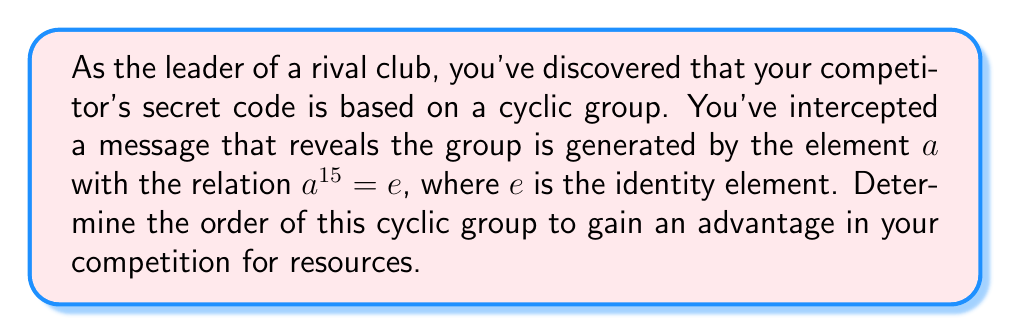Provide a solution to this math problem. To determine the order of a cyclic group generated by an element, we need to find the smallest positive integer $n$ such that $a^n = e$, where $e$ is the identity element of the group.

Given information:
- The group is generated by element $a$
- $a^{15} = e$

Step 1: Consider the possible orders of the group.
The order must be a positive divisor of 15, as $a^{15} = e$. The divisors of 15 are 1, 3, 5, and 15.

Step 2: Eliminate impossible orders.
- Order 1 is impossible because $a \neq e$ (otherwise, the group wouldn't be generated by $a$).
- Orders 3 and 5 are also impossible because if $a^3 = e$ or $a^5 = e$, then $a^{15} = e$ wouldn't be the smallest such exponent.

Step 3: Conclude the order of the group.
The only remaining possibility is 15. This means that $a, a^2, a^3, ..., a^{14}, a^{15} = e$ are all distinct elements of the group.

Therefore, the cyclic group generated by $a$ has order 15.
Answer: The order of the cyclic group is 15. 